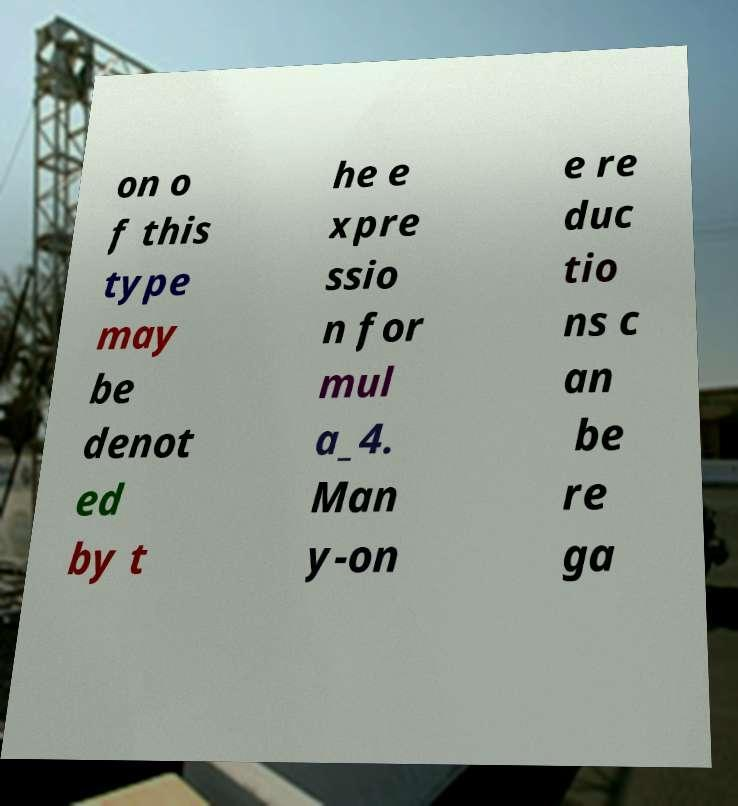There's text embedded in this image that I need extracted. Can you transcribe it verbatim? on o f this type may be denot ed by t he e xpre ssio n for mul a_4. Man y-on e re duc tio ns c an be re ga 